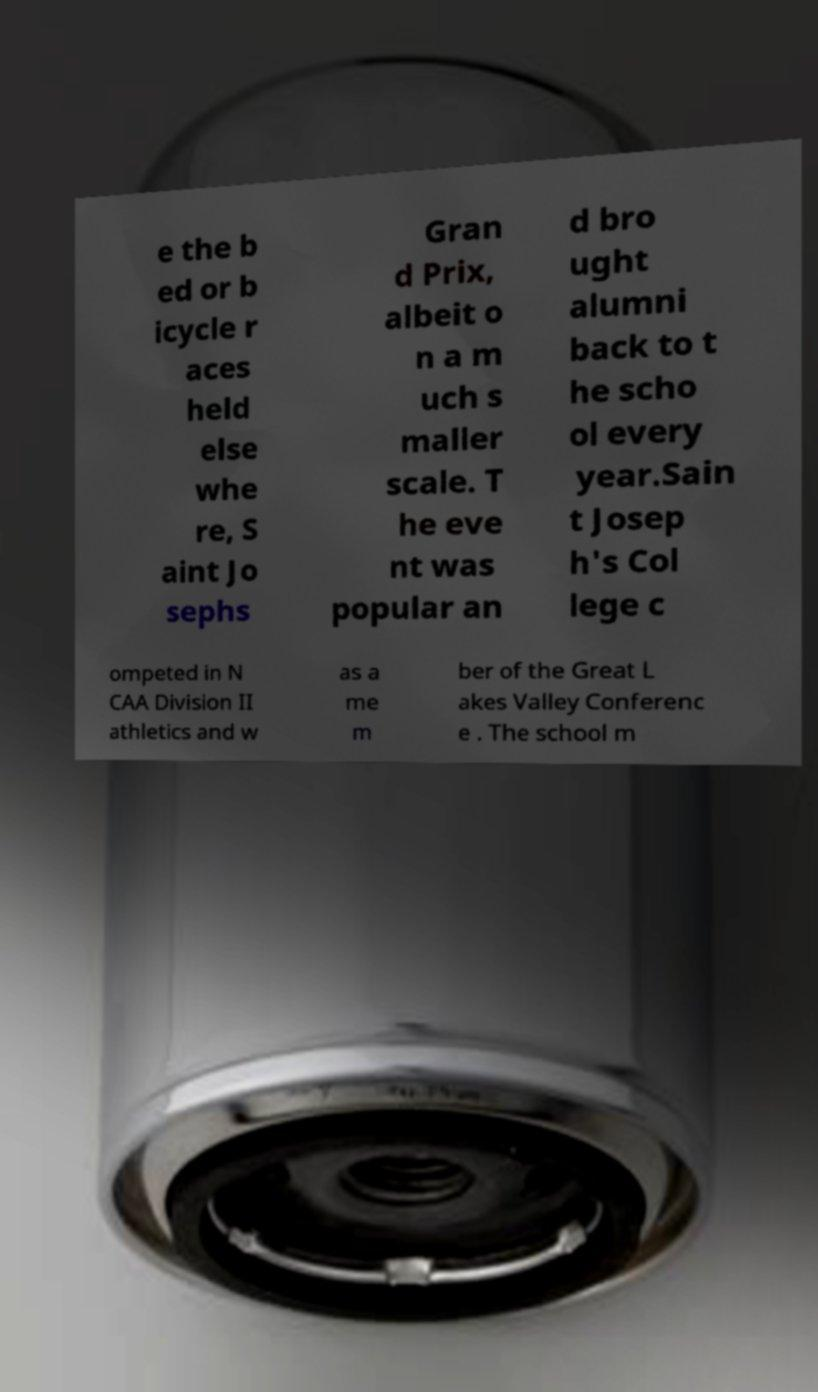Please read and relay the text visible in this image. What does it say? e the b ed or b icycle r aces held else whe re, S aint Jo sephs Gran d Prix, albeit o n a m uch s maller scale. T he eve nt was popular an d bro ught alumni back to t he scho ol every year.Sain t Josep h's Col lege c ompeted in N CAA Division II athletics and w as a me m ber of the Great L akes Valley Conferenc e . The school m 